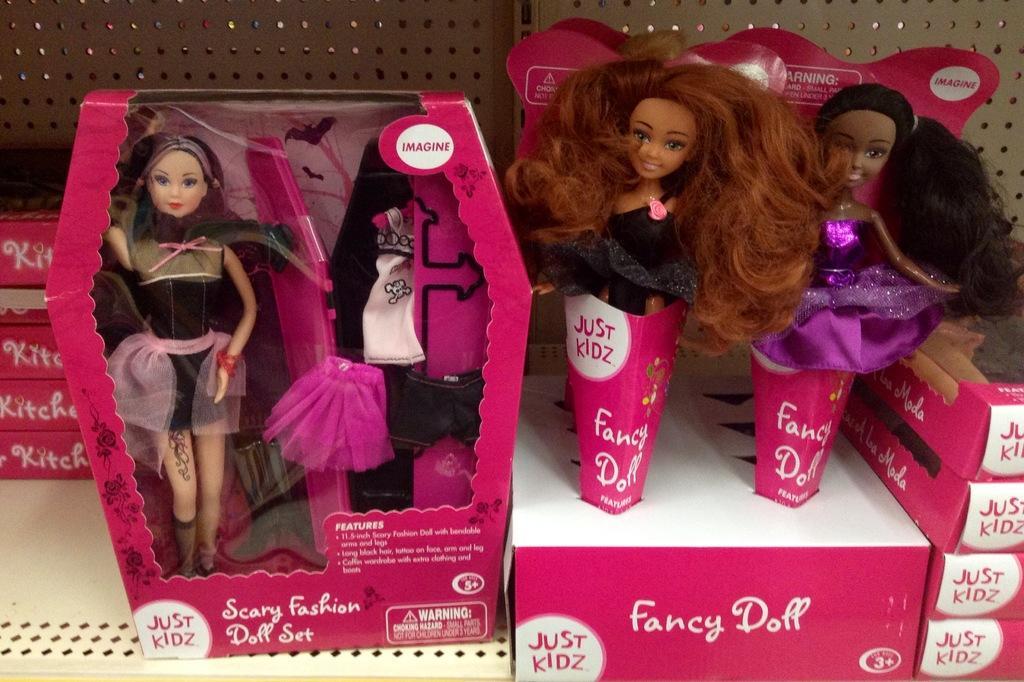Please provide a concise description of this image. The picture consists of dolls and boxes in an iron rack. The boxes are in pink color. 